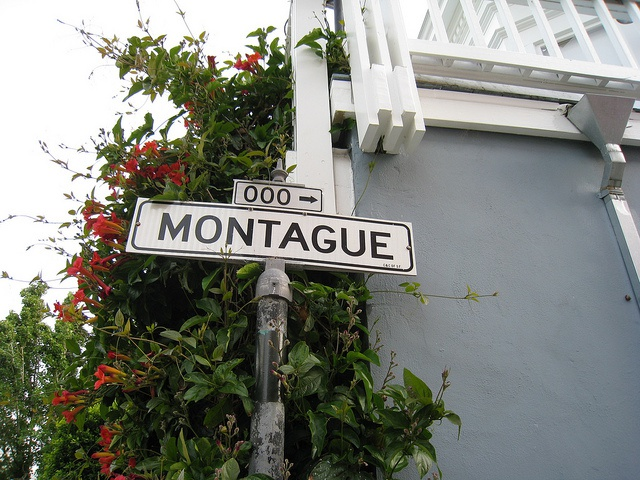Describe the objects in this image and their specific colors. I can see various objects in this image with different colors. 